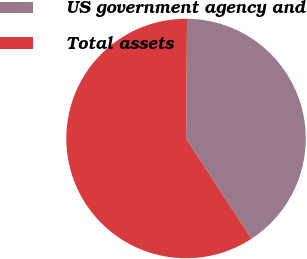Convert chart to OTSL. <chart><loc_0><loc_0><loc_500><loc_500><pie_chart><fcel>US government agency and<fcel>Total assets<nl><fcel>40.67%<fcel>59.33%<nl></chart> 